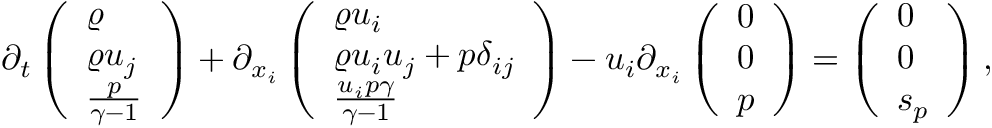Convert formula to latex. <formula><loc_0><loc_0><loc_500><loc_500>\begin{array} { r } { \partial _ { t } \left ( \begin{array} { l } { \varrho } \\ { \varrho u _ { j } } \\ { \frac { p } { \gamma - 1 } } \end{array} \right ) + \partial _ { x _ { i } } \left ( \begin{array} { l } { \varrho u _ { i } } \\ { \varrho u _ { i } u _ { j } + p \delta _ { i j } } \\ { \frac { u _ { i } p \gamma } { \gamma - 1 } } \end{array} \right ) - u _ { i } \partial _ { x _ { i } } \left ( \begin{array} { l } { 0 } \\ { 0 } \\ { p } \end{array} \right ) = \left ( \begin{array} { l } { 0 } \\ { 0 } \\ { s _ { p } } \end{array} \right ) , } \end{array}</formula> 